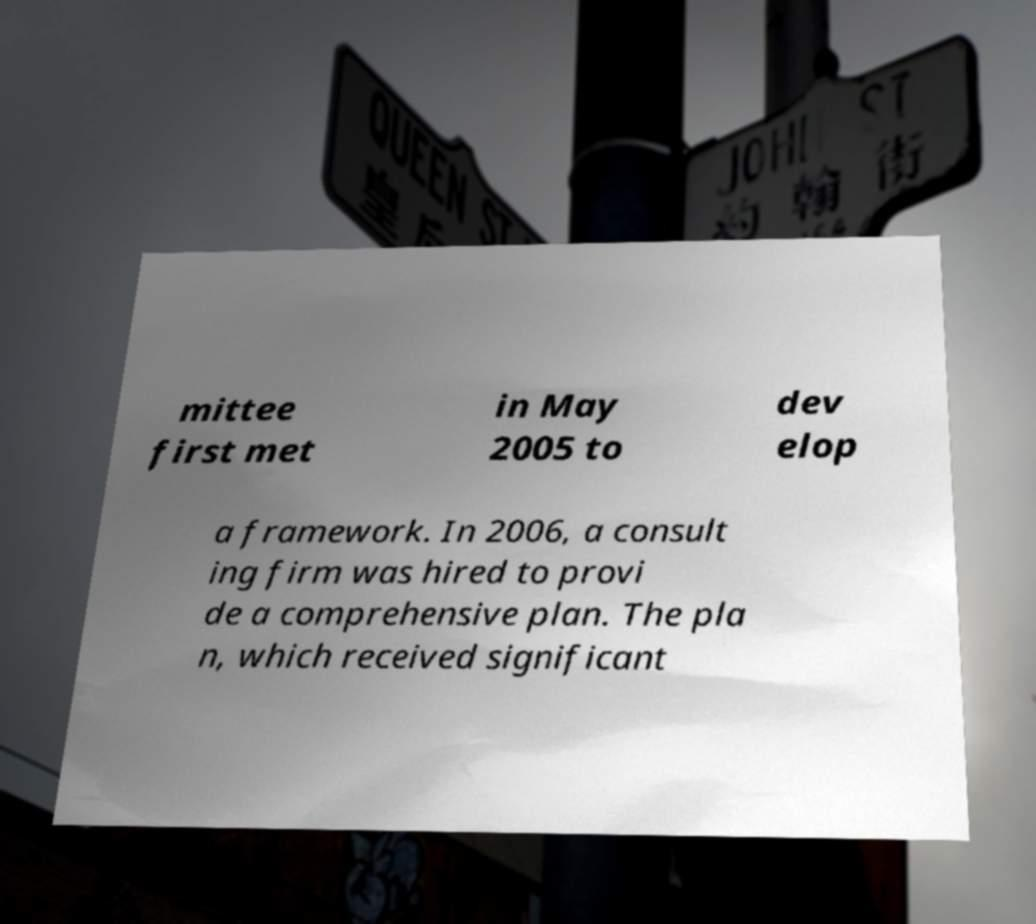Could you extract and type out the text from this image? mittee first met in May 2005 to dev elop a framework. In 2006, a consult ing firm was hired to provi de a comprehensive plan. The pla n, which received significant 